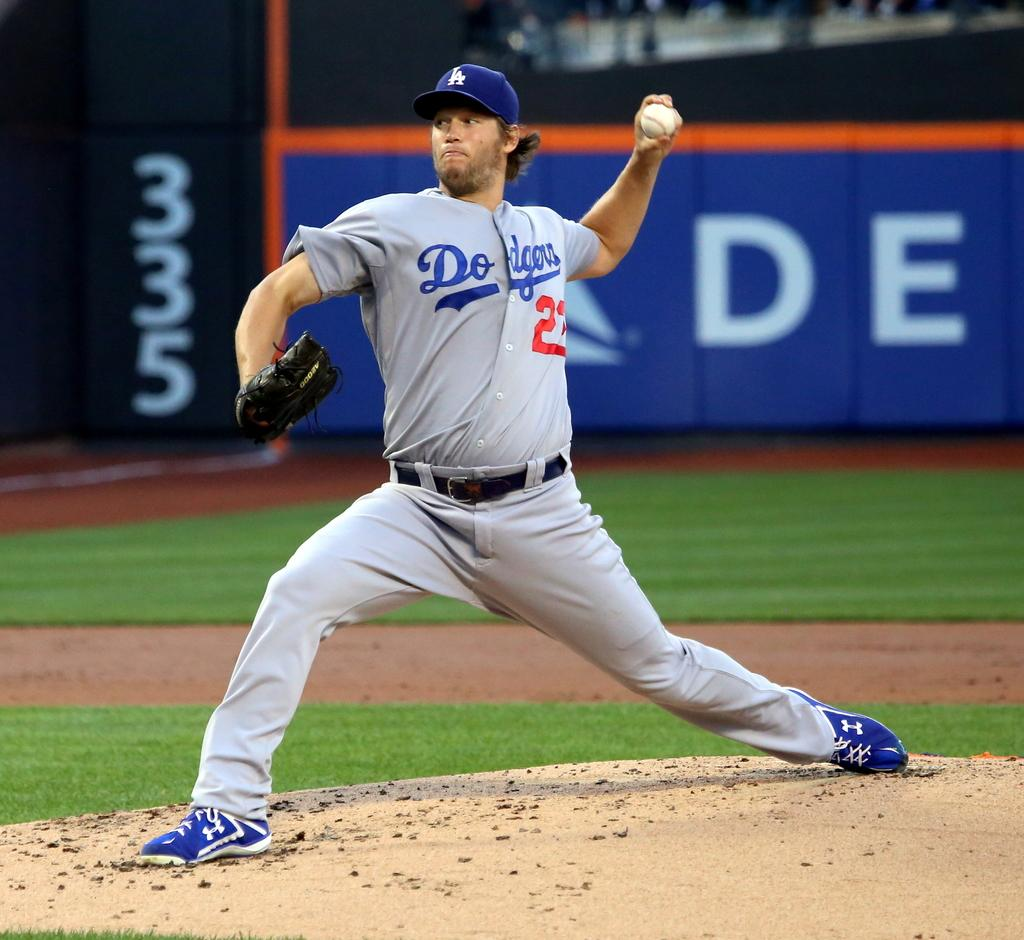<image>
Write a terse but informative summary of the picture. a Dodgers player pitching the ball on the mound 